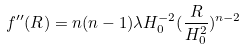<formula> <loc_0><loc_0><loc_500><loc_500>f ^ { \prime \prime } ( R ) = n ( n - 1 ) \lambda H _ { 0 } ^ { - 2 } ( \frac { R } { H _ { 0 } ^ { 2 } } ) ^ { n - 2 }</formula> 